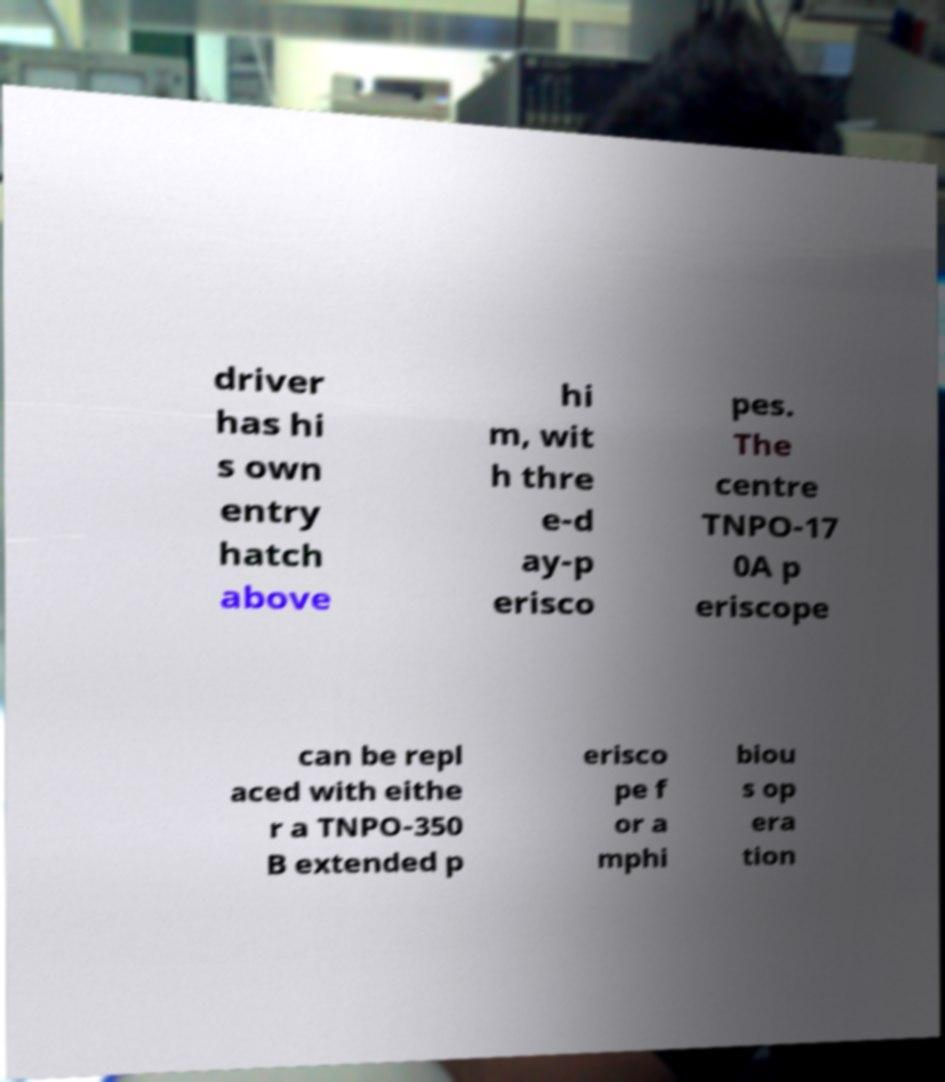Could you extract and type out the text from this image? driver has hi s own entry hatch above hi m, wit h thre e-d ay-p erisco pes. The centre TNPO-17 0A p eriscope can be repl aced with eithe r a TNPO-350 B extended p erisco pe f or a mphi biou s op era tion 